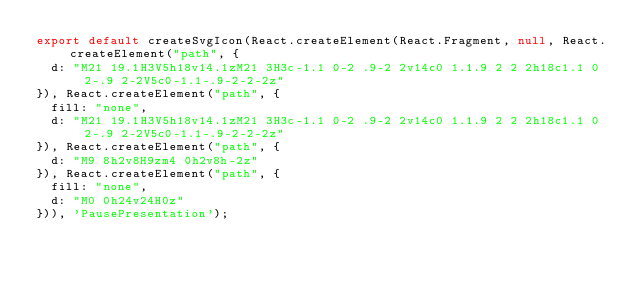Convert code to text. <code><loc_0><loc_0><loc_500><loc_500><_JavaScript_>export default createSvgIcon(React.createElement(React.Fragment, null, React.createElement("path", {
  d: "M21 19.1H3V5h18v14.1zM21 3H3c-1.1 0-2 .9-2 2v14c0 1.1.9 2 2 2h18c1.1 0 2-.9 2-2V5c0-1.1-.9-2-2-2z"
}), React.createElement("path", {
  fill: "none",
  d: "M21 19.1H3V5h18v14.1zM21 3H3c-1.1 0-2 .9-2 2v14c0 1.1.9 2 2 2h18c1.1 0 2-.9 2-2V5c0-1.1-.9-2-2-2z"
}), React.createElement("path", {
  d: "M9 8h2v8H9zm4 0h2v8h-2z"
}), React.createElement("path", {
  fill: "none",
  d: "M0 0h24v24H0z"
})), 'PausePresentation');</code> 